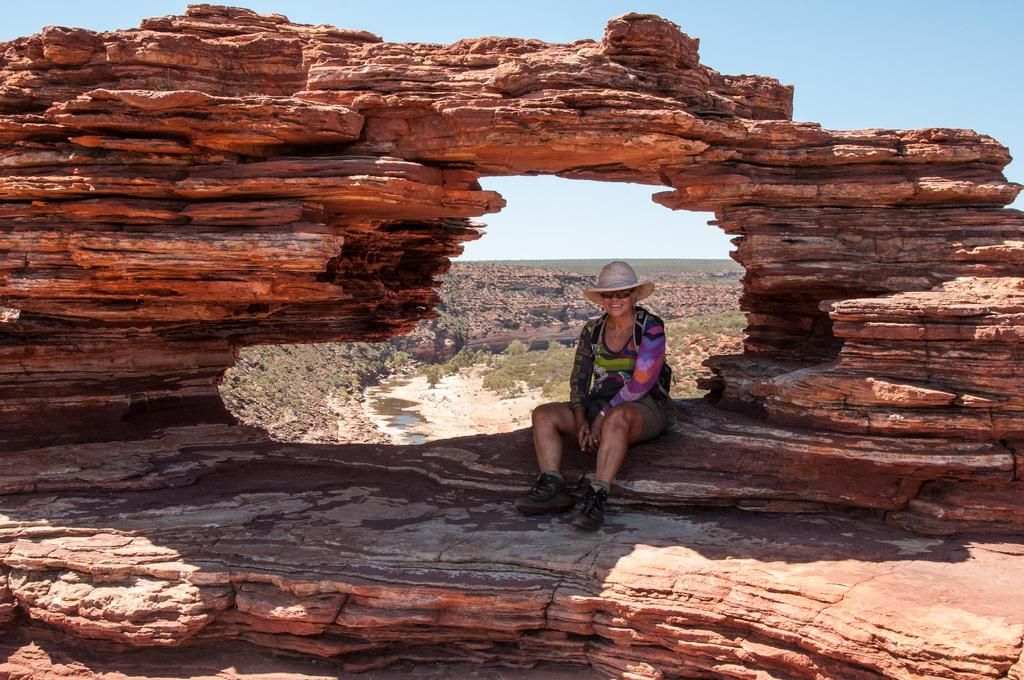Who is the main subject in the image? There is a woman in the image. What is the woman wearing? The woman is wearing a colorful top. Where is the woman sitting? The woman is sitting on a rock. What is the rock part of? The rock is part of a mountain. What can be seen in the background of the image? There are many rocks and trees in the background. What is the color of the sky in the image? The sky is blue and visible at the top of the image. Where is the father of the woman in the image? There is no information about the woman's father in the image, so it cannot be determined. How many geese are visible in the image? There are no geese present in the image. 